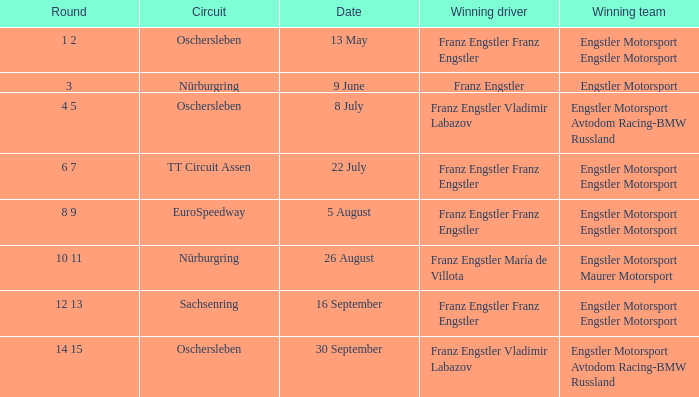What Round was the Winning Team Engstler Motorsport Maurer Motorsport? 10 11. 